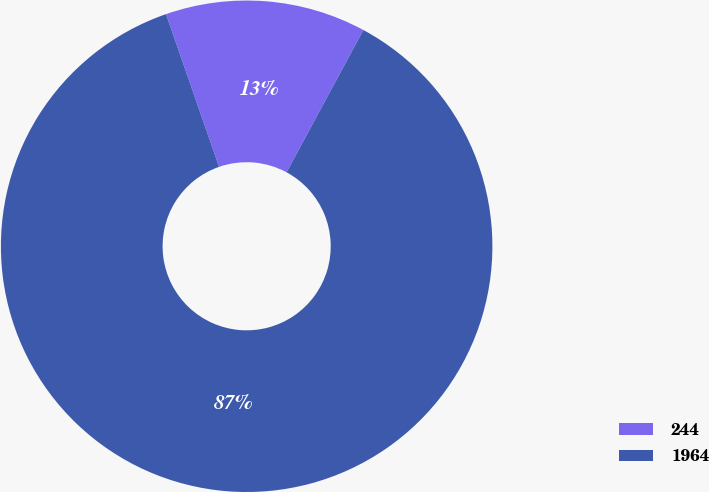Convert chart to OTSL. <chart><loc_0><loc_0><loc_500><loc_500><pie_chart><fcel>244<fcel>1964<nl><fcel>13.2%<fcel>86.8%<nl></chart> 